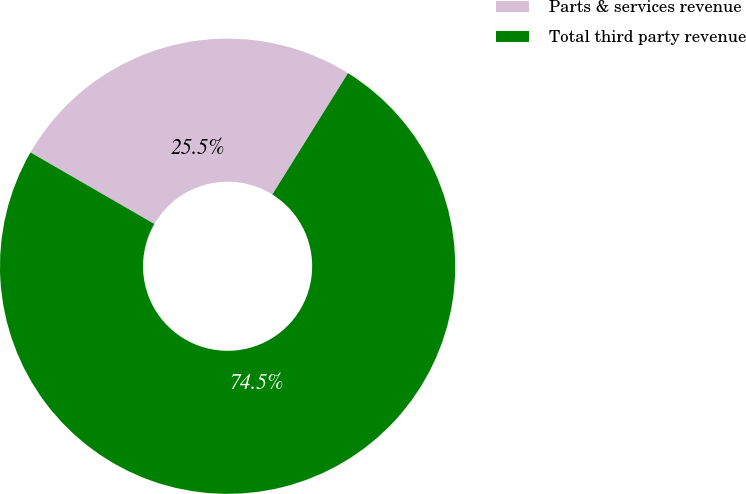<chart> <loc_0><loc_0><loc_500><loc_500><pie_chart><fcel>Parts & services revenue<fcel>Total third party revenue<nl><fcel>25.54%<fcel>74.46%<nl></chart> 